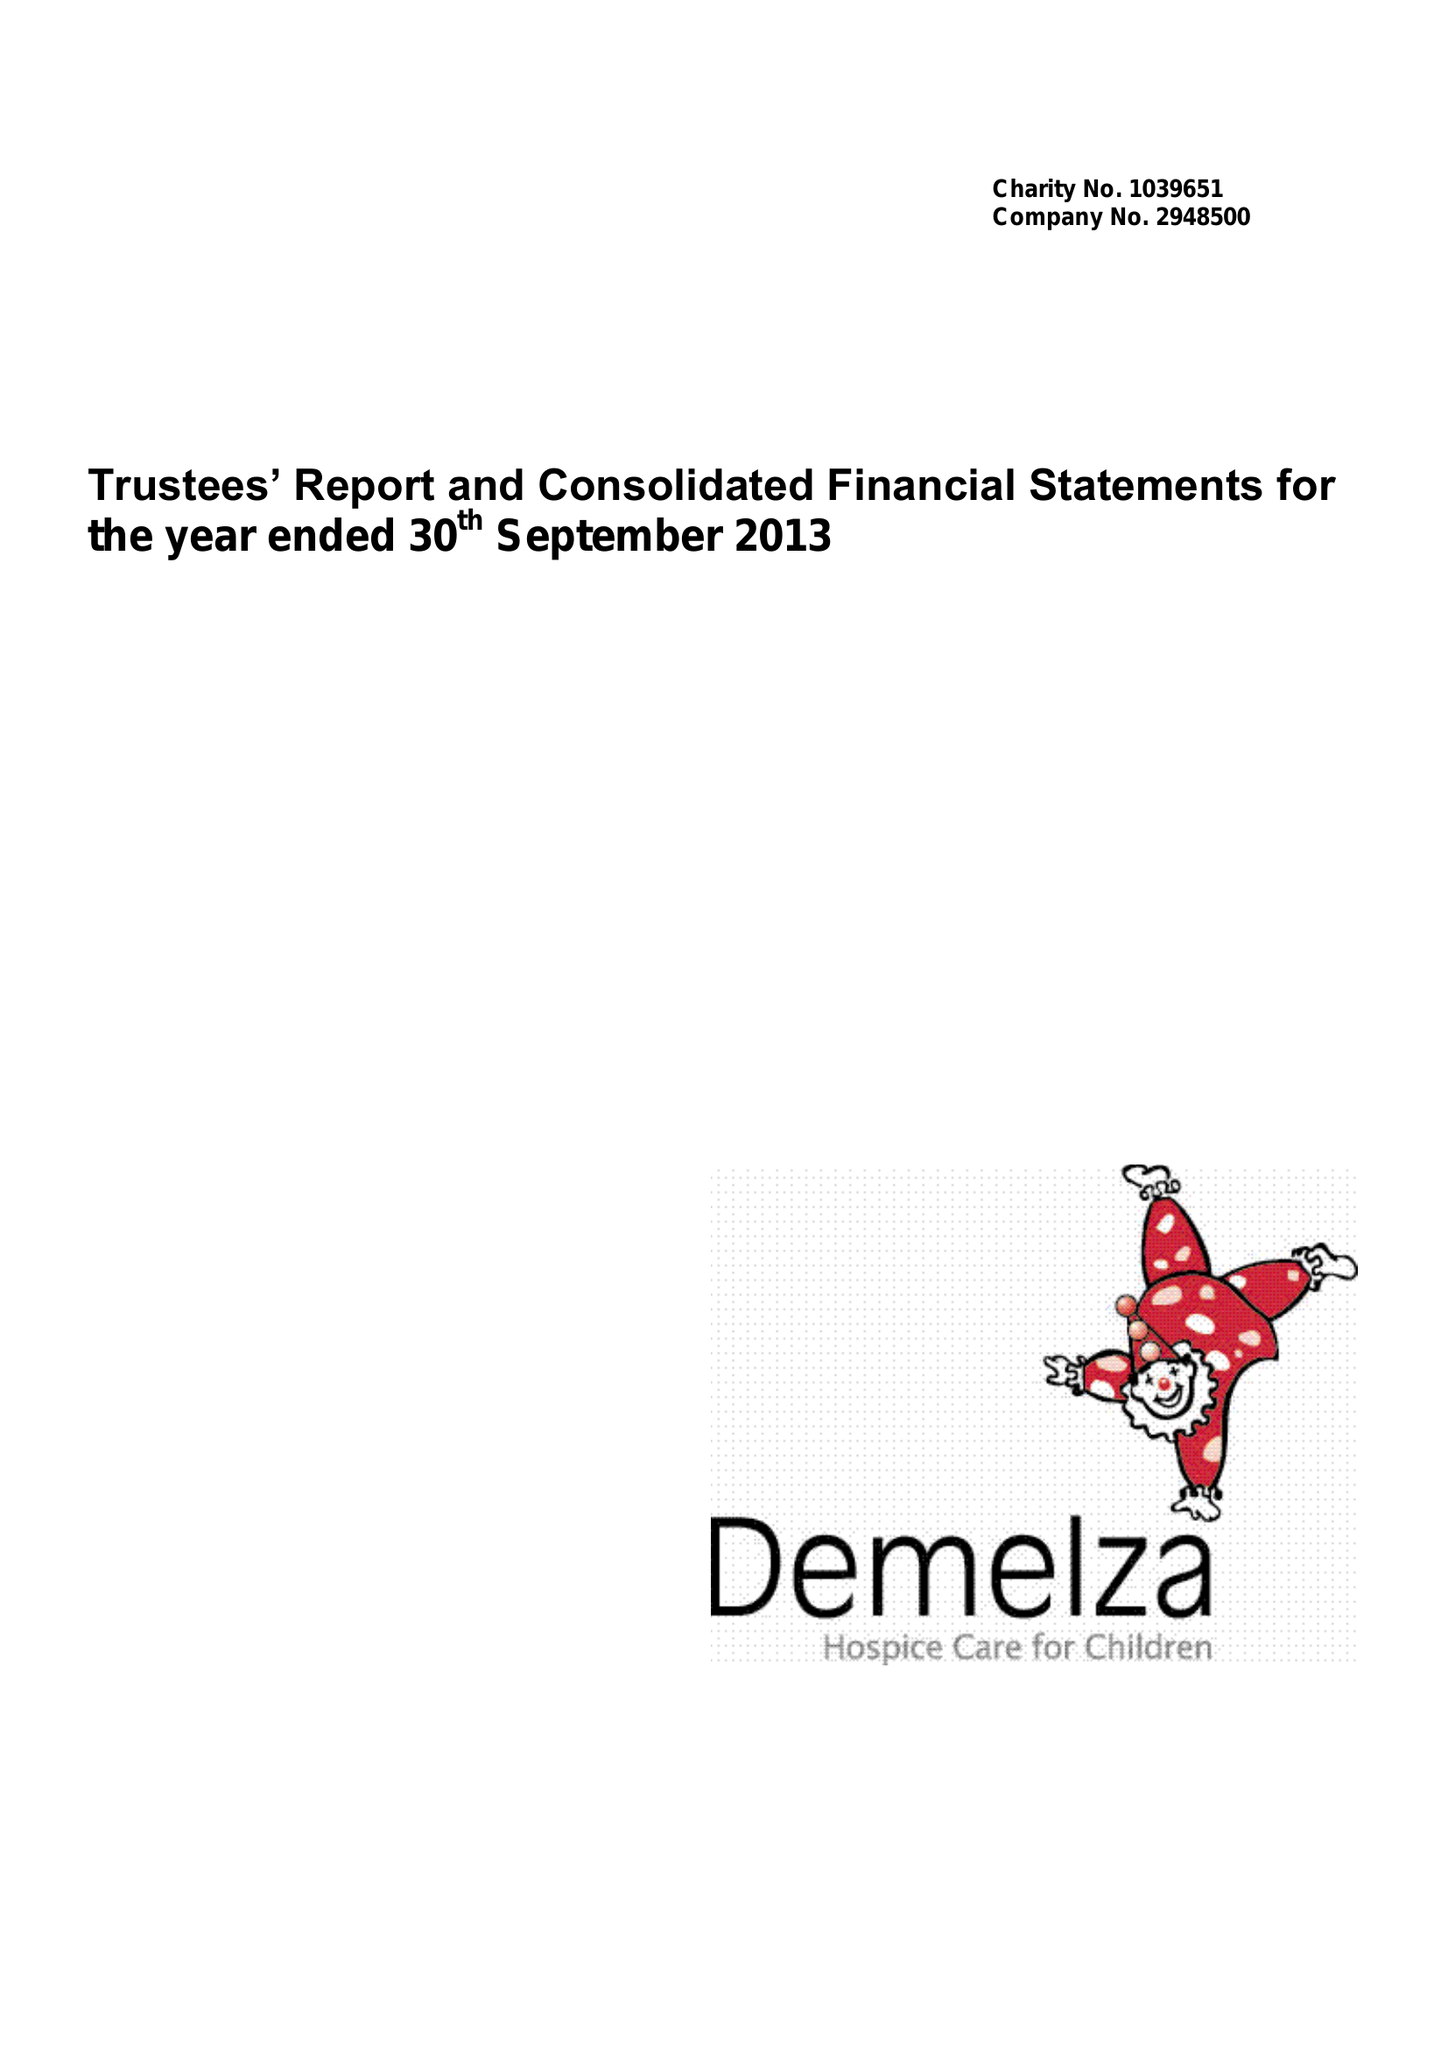What is the value for the address__postcode?
Answer the question using a single word or phrase. ME9 8DZ 